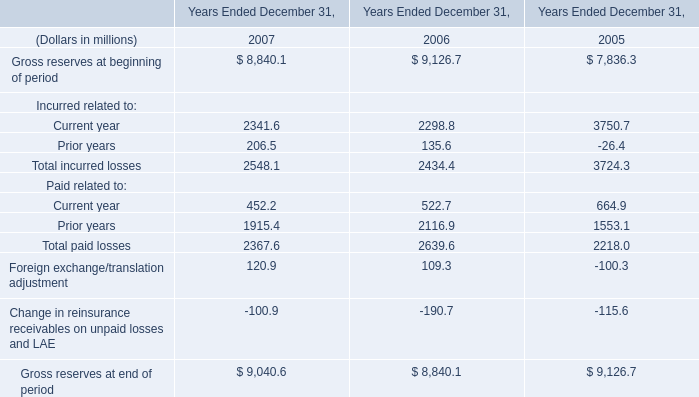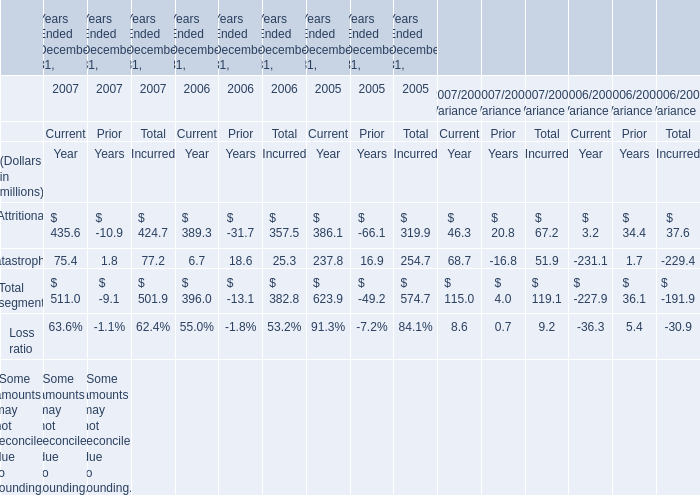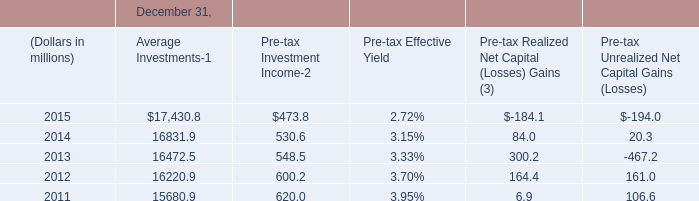In the year with the most Attritional for Total Incurred, what is the growth rate of Catastrophes for Total Incurred? 
Computations: ((77.2 - 25.3) / 25.3)
Answer: 2.05138. 